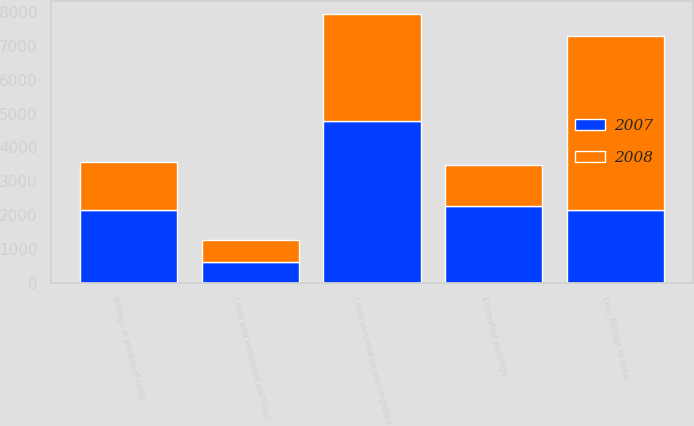Convert chart. <chart><loc_0><loc_0><loc_500><loc_500><stacked_bar_chart><ecel><fcel>Costs incurred on uncompleted<fcel>Estimated earnings<fcel>Less Billings to date<fcel>Costs and estimated earnings<fcel>Billings in excess of costs<nl><fcel>2007<fcel>4776.6<fcel>2277<fcel>2160.7<fcel>618.5<fcel>2160.7<nl><fcel>2008<fcel>3167.2<fcel>1208.3<fcel>5128.1<fcel>643.5<fcel>1396.1<nl></chart> 